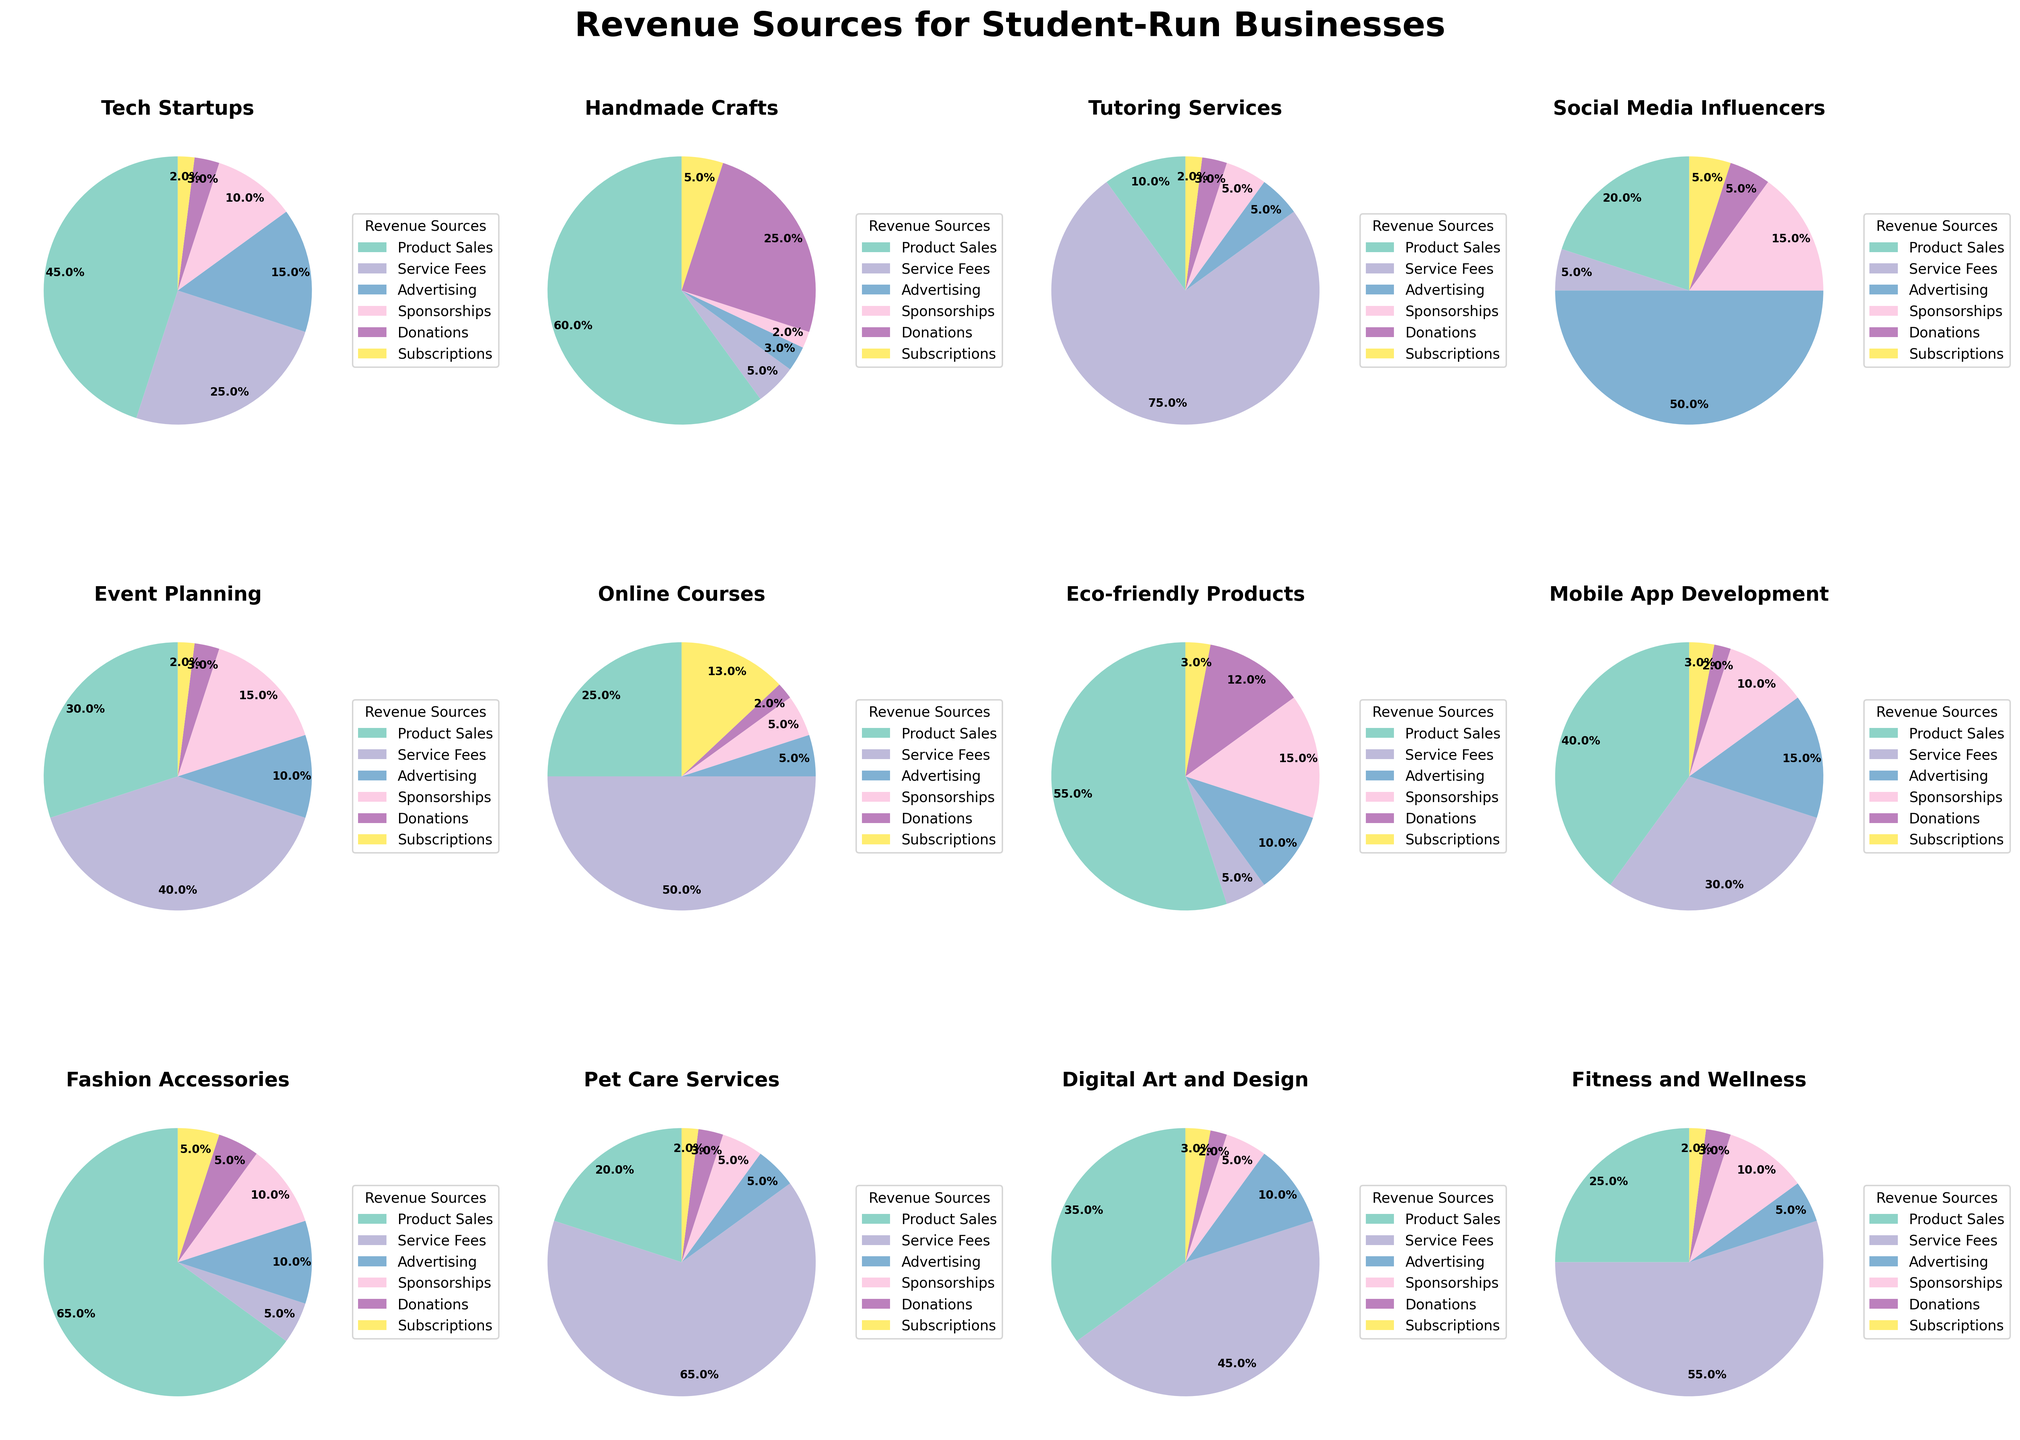Which category has the highest percentage of revenue from Product Sales? By looking at each pie chart, we can see that the category "Fashion Accessories" has the highest percentage of revenue from Product Sales at 65%.
Answer: Fashion Accessories How much revenue percentage comes from Service Fees for Tutoring Services? The pie chart for Tutoring Services shows that Service Fees account for 75% of the revenue.
Answer: 75% Which category generates the least percentage of its revenue from Donations? Comparing the pie charts, Tech Startups, Online Courses, and Fitness and Wellness each have the smallest percentage of revenue from Donations, which is at 2%.
Answer: Tech Startups, Online Courses, Fitness and Wellness For Social Media Influencers, what is the total percentage of revenue from Advertising and Sponsorships combined? In the Social Media Influencers pie chart, Advertising is 50% and Sponsorships are 15%. Adding these together gives us 50% + 15% = 65%.
Answer: 65% Is the percentage of revenue from Subscriptions higher for Online Courses or Eco-friendly Products? By examining the pie charts for both categories, we can see that Online Courses have 13% from Subscriptions while Eco-friendly Products have 3%. Hence, Online Courses have a higher percentage.
Answer: Online Courses What is the difference in the percentage of revenue from Product Sales between Handmade Crafts and Pet Care Services? Handmade Crafts derive 60% of their revenue from Product Sales, while Pet Care Services derive 20%. The difference is 60% - 20% = 40%.
Answer: 40% Which category has an equal percentage of revenue from Service Fees and Sponsorships? From the pie charts, Online Courses have both Service Fees and Sponsorships at 5% each.
Answer: Online Courses What percentage of total revenue comes from Advertising in Tech Startups and Digital Art and Design combined? Tech Startups have 15% from Advertising and Digital Art and Design have 10%. Summing these up gives us 15% + 10% = 25%.
Answer: 25% Which category has its highest revenue source from Service Fees? The pie charts show that Tutoring Services have the highest percentage for Service Fees at 75%.
Answer: Tutoring Services For Event Planning, what is the difference between the percentages of revenue from Product Sales and Donations? Event Planning has 30% from Product Sales and 3% from Donations. The difference is 30% - 3% = 27%.
Answer: 27% 